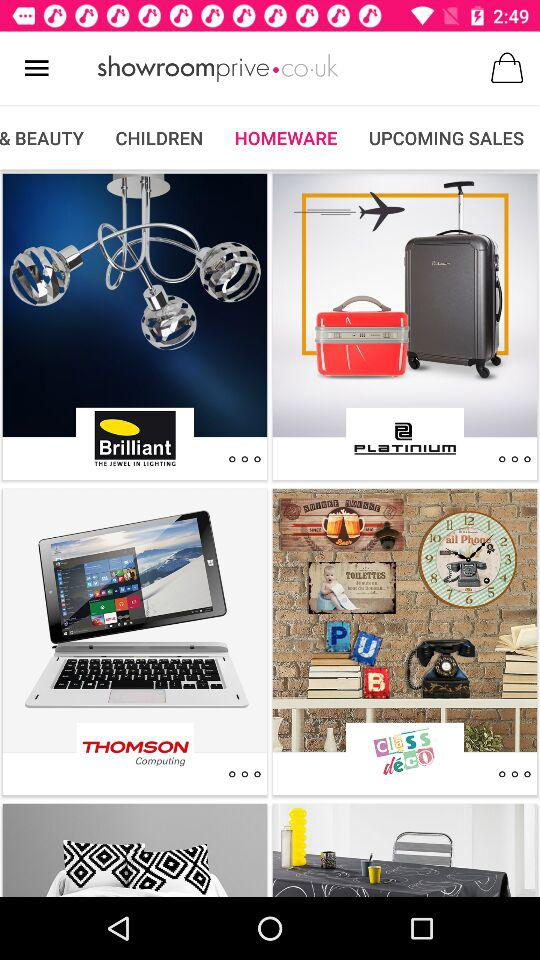What is the shopping website's name? The shopping website's name is "showroomprive.co.uk". 